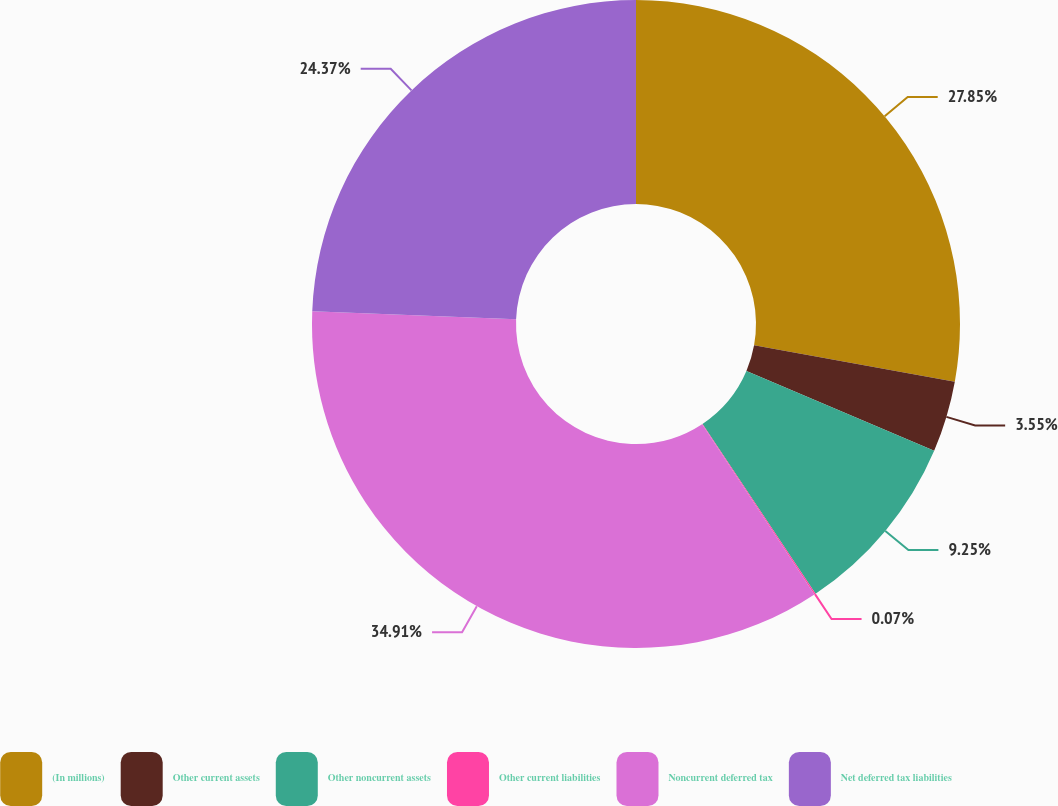<chart> <loc_0><loc_0><loc_500><loc_500><pie_chart><fcel>(In millions)<fcel>Other current assets<fcel>Other noncurrent assets<fcel>Other current liabilities<fcel>Noncurrent deferred tax<fcel>Net deferred tax liabilities<nl><fcel>27.85%<fcel>3.55%<fcel>9.25%<fcel>0.07%<fcel>34.91%<fcel>24.37%<nl></chart> 